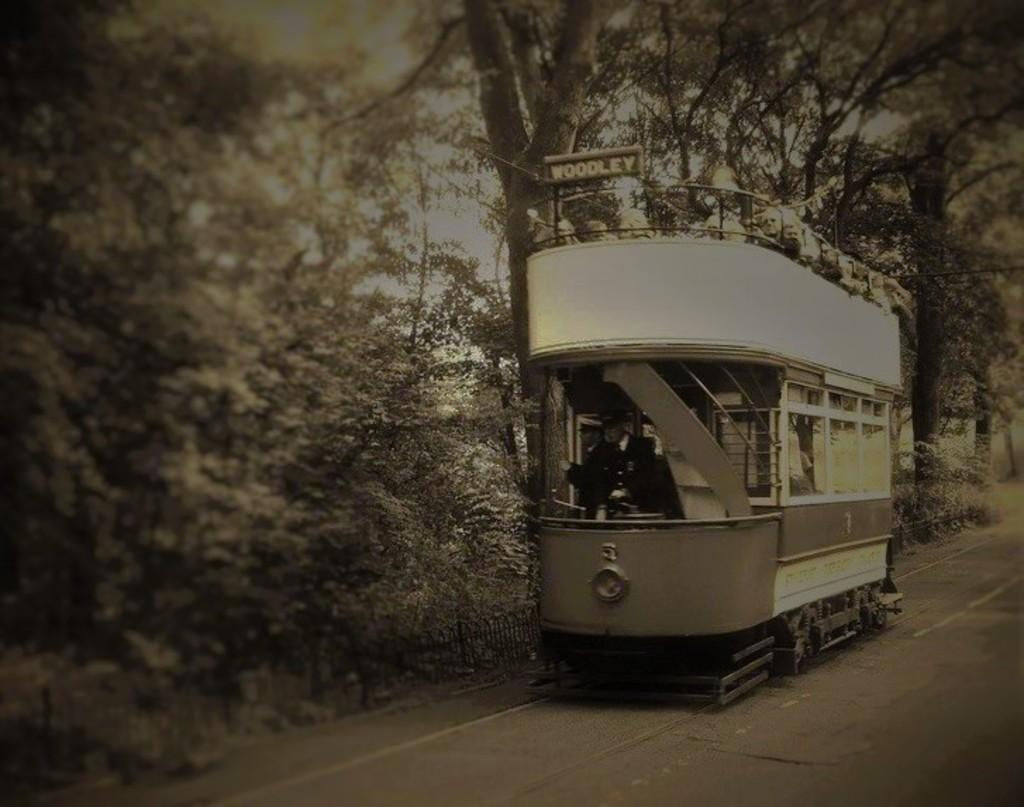Can you describe this image briefly? In the center of the image, we can see some people on the train. In the background, there are trees and at the bottom, there is a road. 